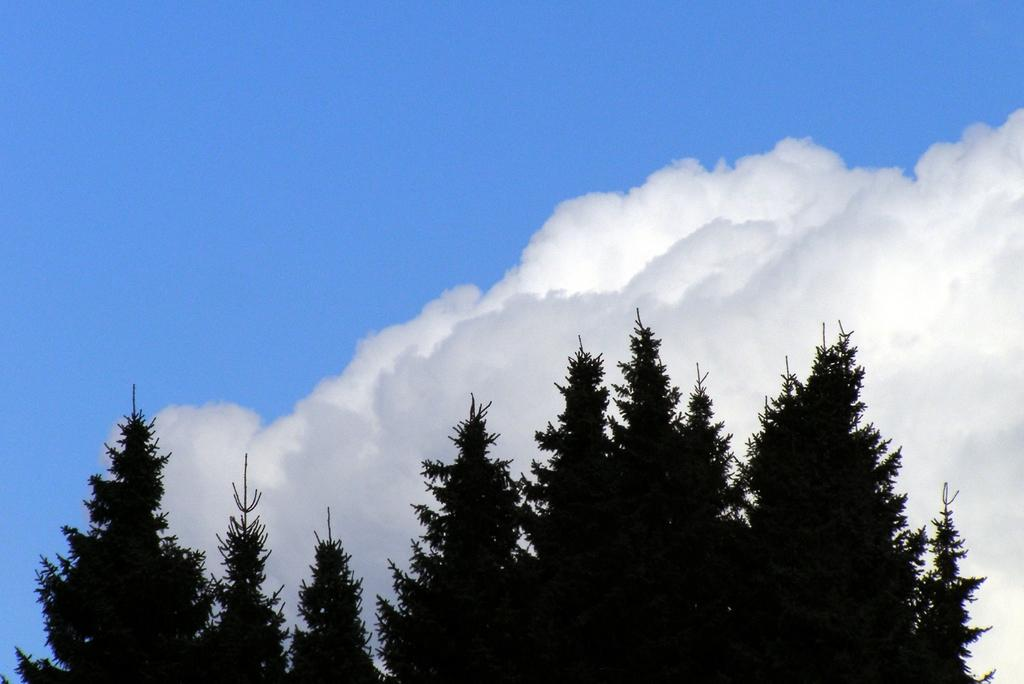What type of vegetation is present at the bottom of the image? There are trees at the bottom of the image. What can be seen in the sky at the top of the image? There are clouds in the sky at the top of the image. What news is being discussed by the friends in the image? There are no friends or news present in the image; it only features trees at the bottom and clouds in the sky at the top. Is the gun being used by anyone in the image? There is no gun present in the image. 